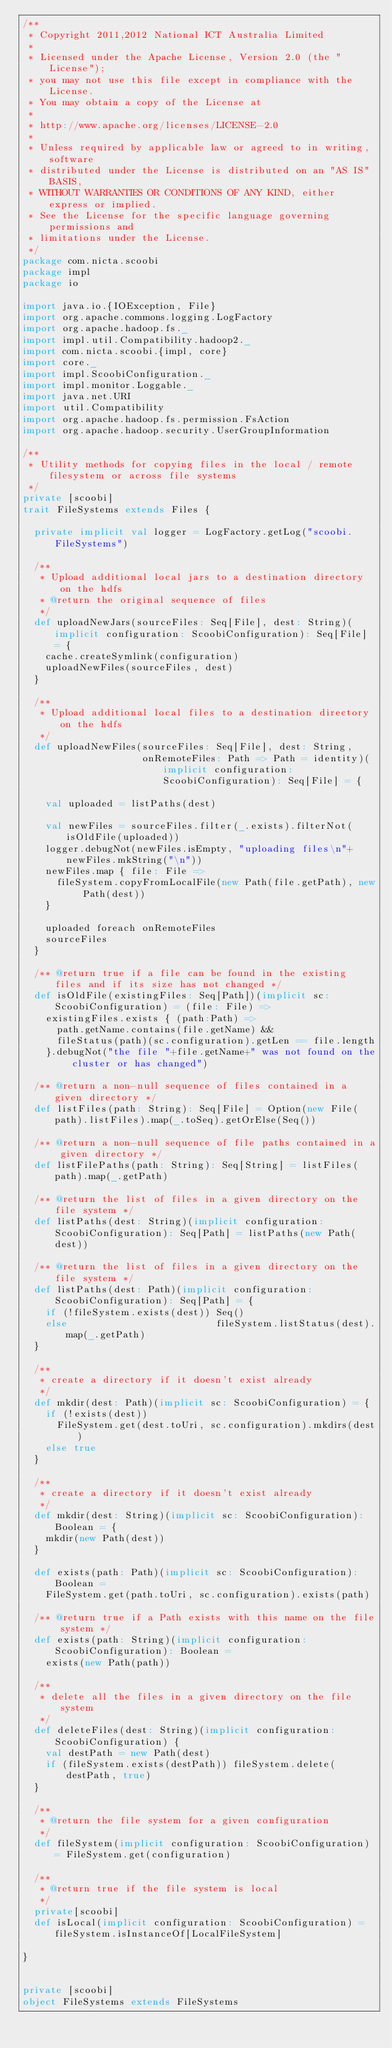Convert code to text. <code><loc_0><loc_0><loc_500><loc_500><_Scala_>/**
 * Copyright 2011,2012 National ICT Australia Limited
 *
 * Licensed under the Apache License, Version 2.0 (the "License");
 * you may not use this file except in compliance with the License.
 * You may obtain a copy of the License at
 *
 * http://www.apache.org/licenses/LICENSE-2.0
 *
 * Unless required by applicable law or agreed to in writing, software
 * distributed under the License is distributed on an "AS IS" BASIS,
 * WITHOUT WARRANTIES OR CONDITIONS OF ANY KIND, either express or implied.
 * See the License for the specific language governing permissions and
 * limitations under the License.
 */
package com.nicta.scoobi
package impl
package io

import java.io.{IOException, File}
import org.apache.commons.logging.LogFactory
import org.apache.hadoop.fs._
import impl.util.Compatibility.hadoop2._
import com.nicta.scoobi.{impl, core}
import core._
import impl.ScoobiConfiguration._
import impl.monitor.Loggable._
import java.net.URI
import util.Compatibility
import org.apache.hadoop.fs.permission.FsAction
import org.apache.hadoop.security.UserGroupInformation

/**
 * Utility methods for copying files in the local / remote filesystem or across file systems
 */
private [scoobi]
trait FileSystems extends Files {

  private implicit val logger = LogFactory.getLog("scoobi.FileSystems")

  /**
   * Upload additional local jars to a destination directory on the hdfs
   * @return the original sequence of files
   */
  def uploadNewJars(sourceFiles: Seq[File], dest: String)(implicit configuration: ScoobiConfiguration): Seq[File] = {
    cache.createSymlink(configuration)
    uploadNewFiles(sourceFiles, dest)
  }

  /**
   * Upload additional local files to a destination directory on the hdfs
   */
  def uploadNewFiles(sourceFiles: Seq[File], dest: String,
                     onRemoteFiles: Path => Path = identity)(implicit configuration: ScoobiConfiguration): Seq[File] = {

    val uploaded = listPaths(dest)

    val newFiles = sourceFiles.filter(_.exists).filterNot(isOldFile(uploaded))
    logger.debugNot(newFiles.isEmpty, "uploading files\n"+newFiles.mkString("\n"))
    newFiles.map { file: File =>
      fileSystem.copyFromLocalFile(new Path(file.getPath), new Path(dest))
    }

    uploaded foreach onRemoteFiles
    sourceFiles
  }

  /** @return true if a file can be found in the existing files and if its size has not changed */
  def isOldFile(existingFiles: Seq[Path])(implicit sc: ScoobiConfiguration) = (file: File) =>
    existingFiles.exists { (path:Path) =>
      path.getName.contains(file.getName) &&
      fileStatus(path)(sc.configuration).getLen == file.length
    }.debugNot("the file "+file.getName+" was not found on the cluster or has changed")

  /** @return a non-null sequence of files contained in a given directory */
  def listFiles(path: String): Seq[File] = Option(new File(path).listFiles).map(_.toSeq).getOrElse(Seq())

  /** @return a non-null sequence of file paths contained in a given directory */
  def listFilePaths(path: String): Seq[String] = listFiles(path).map(_.getPath)

  /** @return the list of files in a given directory on the file system */
  def listPaths(dest: String)(implicit configuration: ScoobiConfiguration): Seq[Path] = listPaths(new Path(dest))

  /** @return the list of files in a given directory on the file system */
  def listPaths(dest: Path)(implicit configuration: ScoobiConfiguration): Seq[Path] = {
    if (!fileSystem.exists(dest)) Seq()
    else                          fileSystem.listStatus(dest).map(_.getPath)
  }

  /**
   * create a directory if it doesn't exist already
   */
  def mkdir(dest: Path)(implicit sc: ScoobiConfiguration) = {
    if (!exists(dest))
      FileSystem.get(dest.toUri, sc.configuration).mkdirs(dest)
    else true
  }

  /**
   * create a directory if it doesn't exist already
   */
  def mkdir(dest: String)(implicit sc: ScoobiConfiguration): Boolean = {
    mkdir(new Path(dest))
  }

  def exists(path: Path)(implicit sc: ScoobiConfiguration): Boolean =
    FileSystem.get(path.toUri, sc.configuration).exists(path)

  /** @return true if a Path exists with this name on the file system */
  def exists(path: String)(implicit configuration: ScoobiConfiguration): Boolean =
    exists(new Path(path))

  /**
   * delete all the files in a given directory on the file system
   */
  def deleteFiles(dest: String)(implicit configuration: ScoobiConfiguration) {
    val destPath = new Path(dest)
    if (fileSystem.exists(destPath)) fileSystem.delete(destPath, true)
  }

  /**
   * @return the file system for a given configuration
   */
  def fileSystem(implicit configuration: ScoobiConfiguration) = FileSystem.get(configuration)

  /**
   * @return true if the file system is local
   */
  private[scoobi]
  def isLocal(implicit configuration: ScoobiConfiguration) = fileSystem.isInstanceOf[LocalFileSystem]

}


private [scoobi]
object FileSystems extends FileSystems
</code> 